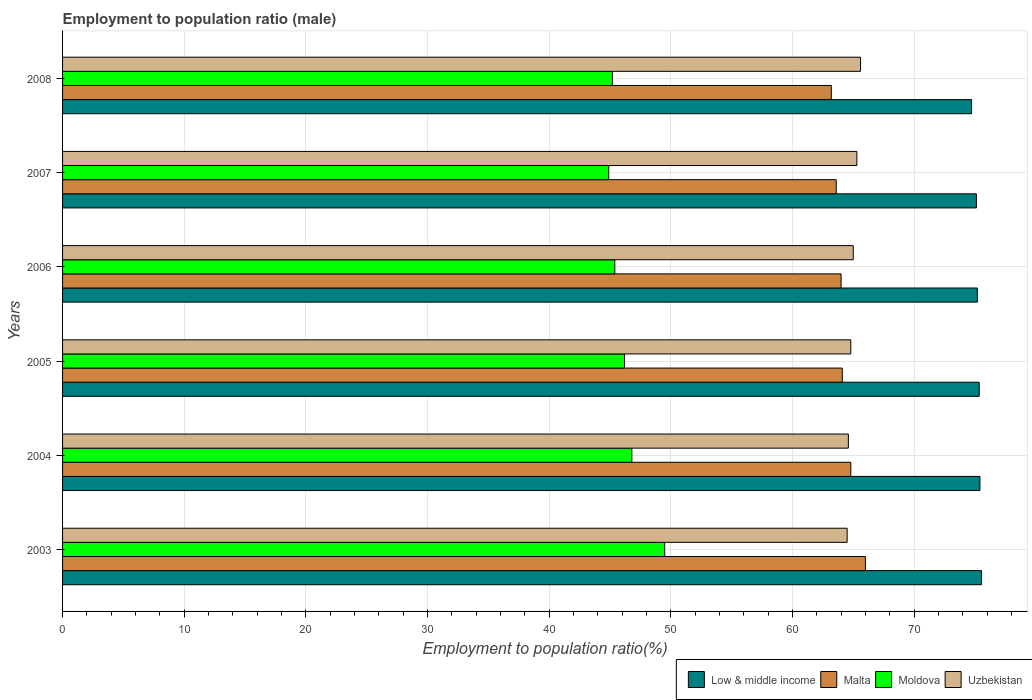Are the number of bars per tick equal to the number of legend labels?
Keep it short and to the point. Yes. Are the number of bars on each tick of the Y-axis equal?
Provide a succinct answer. Yes. How many bars are there on the 5th tick from the top?
Provide a succinct answer. 4. How many bars are there on the 5th tick from the bottom?
Keep it short and to the point. 4. In how many cases, is the number of bars for a given year not equal to the number of legend labels?
Offer a very short reply. 0. What is the employment to population ratio in Low & middle income in 2004?
Ensure brevity in your answer.  75.41. Across all years, what is the maximum employment to population ratio in Malta?
Make the answer very short. 66. Across all years, what is the minimum employment to population ratio in Moldova?
Your answer should be very brief. 44.9. In which year was the employment to population ratio in Low & middle income minimum?
Your answer should be very brief. 2008. What is the total employment to population ratio in Uzbekistan in the graph?
Offer a very short reply. 389.8. What is the difference between the employment to population ratio in Low & middle income in 2003 and that in 2007?
Your answer should be very brief. 0.42. What is the difference between the employment to population ratio in Low & middle income in 2008 and the employment to population ratio in Moldova in 2007?
Provide a short and direct response. 29.83. What is the average employment to population ratio in Moldova per year?
Make the answer very short. 46.33. In the year 2005, what is the difference between the employment to population ratio in Low & middle income and employment to population ratio in Malta?
Keep it short and to the point. 11.26. In how many years, is the employment to population ratio in Malta greater than 48 %?
Your response must be concise. 6. What is the ratio of the employment to population ratio in Low & middle income in 2003 to that in 2006?
Keep it short and to the point. 1. Is the employment to population ratio in Uzbekistan in 2003 less than that in 2004?
Offer a very short reply. Yes. What is the difference between the highest and the second highest employment to population ratio in Uzbekistan?
Give a very brief answer. 0.3. What is the difference between the highest and the lowest employment to population ratio in Malta?
Ensure brevity in your answer.  2.8. In how many years, is the employment to population ratio in Low & middle income greater than the average employment to population ratio in Low & middle income taken over all years?
Offer a very short reply. 3. Is the sum of the employment to population ratio in Low & middle income in 2004 and 2007 greater than the maximum employment to population ratio in Malta across all years?
Your response must be concise. Yes. What does the 3rd bar from the top in 2007 represents?
Your response must be concise. Malta. Is it the case that in every year, the sum of the employment to population ratio in Malta and employment to population ratio in Uzbekistan is greater than the employment to population ratio in Low & middle income?
Provide a succinct answer. Yes. How many bars are there?
Provide a succinct answer. 24. Are all the bars in the graph horizontal?
Provide a succinct answer. Yes. Are the values on the major ticks of X-axis written in scientific E-notation?
Keep it short and to the point. No. Does the graph contain any zero values?
Provide a short and direct response. No. Where does the legend appear in the graph?
Ensure brevity in your answer.  Bottom right. How many legend labels are there?
Provide a short and direct response. 4. What is the title of the graph?
Offer a very short reply. Employment to population ratio (male). What is the label or title of the X-axis?
Ensure brevity in your answer.  Employment to population ratio(%). What is the Employment to population ratio(%) of Low & middle income in 2003?
Make the answer very short. 75.55. What is the Employment to population ratio(%) in Malta in 2003?
Provide a succinct answer. 66. What is the Employment to population ratio(%) in Moldova in 2003?
Keep it short and to the point. 49.5. What is the Employment to population ratio(%) in Uzbekistan in 2003?
Make the answer very short. 64.5. What is the Employment to population ratio(%) of Low & middle income in 2004?
Your answer should be very brief. 75.41. What is the Employment to population ratio(%) in Malta in 2004?
Make the answer very short. 64.8. What is the Employment to population ratio(%) in Moldova in 2004?
Your response must be concise. 46.8. What is the Employment to population ratio(%) in Uzbekistan in 2004?
Offer a very short reply. 64.6. What is the Employment to population ratio(%) of Low & middle income in 2005?
Your response must be concise. 75.36. What is the Employment to population ratio(%) in Malta in 2005?
Make the answer very short. 64.1. What is the Employment to population ratio(%) of Moldova in 2005?
Your answer should be compact. 46.2. What is the Employment to population ratio(%) of Uzbekistan in 2005?
Your response must be concise. 64.8. What is the Employment to population ratio(%) of Low & middle income in 2006?
Offer a very short reply. 75.2. What is the Employment to population ratio(%) in Moldova in 2006?
Make the answer very short. 45.4. What is the Employment to population ratio(%) in Low & middle income in 2007?
Your response must be concise. 75.13. What is the Employment to population ratio(%) of Malta in 2007?
Give a very brief answer. 63.6. What is the Employment to population ratio(%) of Moldova in 2007?
Give a very brief answer. 44.9. What is the Employment to population ratio(%) of Uzbekistan in 2007?
Offer a very short reply. 65.3. What is the Employment to population ratio(%) of Low & middle income in 2008?
Ensure brevity in your answer.  74.73. What is the Employment to population ratio(%) of Malta in 2008?
Ensure brevity in your answer.  63.2. What is the Employment to population ratio(%) in Moldova in 2008?
Your answer should be very brief. 45.2. What is the Employment to population ratio(%) of Uzbekistan in 2008?
Provide a short and direct response. 65.6. Across all years, what is the maximum Employment to population ratio(%) of Low & middle income?
Provide a short and direct response. 75.55. Across all years, what is the maximum Employment to population ratio(%) in Moldova?
Make the answer very short. 49.5. Across all years, what is the maximum Employment to population ratio(%) in Uzbekistan?
Offer a terse response. 65.6. Across all years, what is the minimum Employment to population ratio(%) of Low & middle income?
Offer a terse response. 74.73. Across all years, what is the minimum Employment to population ratio(%) in Malta?
Your answer should be compact. 63.2. Across all years, what is the minimum Employment to population ratio(%) of Moldova?
Keep it short and to the point. 44.9. Across all years, what is the minimum Employment to population ratio(%) of Uzbekistan?
Ensure brevity in your answer.  64.5. What is the total Employment to population ratio(%) in Low & middle income in the graph?
Ensure brevity in your answer.  451.38. What is the total Employment to population ratio(%) of Malta in the graph?
Offer a very short reply. 385.7. What is the total Employment to population ratio(%) of Moldova in the graph?
Offer a terse response. 278. What is the total Employment to population ratio(%) in Uzbekistan in the graph?
Provide a short and direct response. 389.8. What is the difference between the Employment to population ratio(%) in Low & middle income in 2003 and that in 2004?
Offer a terse response. 0.13. What is the difference between the Employment to population ratio(%) of Uzbekistan in 2003 and that in 2004?
Make the answer very short. -0.1. What is the difference between the Employment to population ratio(%) of Low & middle income in 2003 and that in 2005?
Your answer should be very brief. 0.19. What is the difference between the Employment to population ratio(%) in Low & middle income in 2003 and that in 2006?
Your answer should be very brief. 0.35. What is the difference between the Employment to population ratio(%) in Malta in 2003 and that in 2006?
Keep it short and to the point. 2. What is the difference between the Employment to population ratio(%) of Moldova in 2003 and that in 2006?
Provide a succinct answer. 4.1. What is the difference between the Employment to population ratio(%) of Uzbekistan in 2003 and that in 2006?
Your answer should be very brief. -0.5. What is the difference between the Employment to population ratio(%) of Low & middle income in 2003 and that in 2007?
Offer a terse response. 0.42. What is the difference between the Employment to population ratio(%) in Malta in 2003 and that in 2007?
Provide a succinct answer. 2.4. What is the difference between the Employment to population ratio(%) in Low & middle income in 2003 and that in 2008?
Your response must be concise. 0.82. What is the difference between the Employment to population ratio(%) in Uzbekistan in 2003 and that in 2008?
Give a very brief answer. -1.1. What is the difference between the Employment to population ratio(%) in Low & middle income in 2004 and that in 2005?
Your answer should be compact. 0.06. What is the difference between the Employment to population ratio(%) of Malta in 2004 and that in 2005?
Your response must be concise. 0.7. What is the difference between the Employment to population ratio(%) of Moldova in 2004 and that in 2005?
Your answer should be very brief. 0.6. What is the difference between the Employment to population ratio(%) of Uzbekistan in 2004 and that in 2005?
Keep it short and to the point. -0.2. What is the difference between the Employment to population ratio(%) of Low & middle income in 2004 and that in 2006?
Give a very brief answer. 0.21. What is the difference between the Employment to population ratio(%) in Moldova in 2004 and that in 2006?
Provide a succinct answer. 1.4. What is the difference between the Employment to population ratio(%) in Uzbekistan in 2004 and that in 2006?
Your answer should be compact. -0.4. What is the difference between the Employment to population ratio(%) of Low & middle income in 2004 and that in 2007?
Provide a succinct answer. 0.29. What is the difference between the Employment to population ratio(%) in Moldova in 2004 and that in 2007?
Offer a very short reply. 1.9. What is the difference between the Employment to population ratio(%) in Uzbekistan in 2004 and that in 2007?
Provide a short and direct response. -0.7. What is the difference between the Employment to population ratio(%) of Low & middle income in 2004 and that in 2008?
Your response must be concise. 0.69. What is the difference between the Employment to population ratio(%) in Malta in 2004 and that in 2008?
Ensure brevity in your answer.  1.6. What is the difference between the Employment to population ratio(%) of Uzbekistan in 2004 and that in 2008?
Your answer should be very brief. -1. What is the difference between the Employment to population ratio(%) in Low & middle income in 2005 and that in 2006?
Your response must be concise. 0.15. What is the difference between the Employment to population ratio(%) of Low & middle income in 2005 and that in 2007?
Your response must be concise. 0.23. What is the difference between the Employment to population ratio(%) of Malta in 2005 and that in 2007?
Your response must be concise. 0.5. What is the difference between the Employment to population ratio(%) in Uzbekistan in 2005 and that in 2007?
Your answer should be very brief. -0.5. What is the difference between the Employment to population ratio(%) in Low & middle income in 2005 and that in 2008?
Make the answer very short. 0.63. What is the difference between the Employment to population ratio(%) in Moldova in 2005 and that in 2008?
Your answer should be very brief. 1. What is the difference between the Employment to population ratio(%) in Low & middle income in 2006 and that in 2007?
Your answer should be very brief. 0.08. What is the difference between the Employment to population ratio(%) in Low & middle income in 2006 and that in 2008?
Provide a short and direct response. 0.47. What is the difference between the Employment to population ratio(%) of Uzbekistan in 2006 and that in 2008?
Make the answer very short. -0.6. What is the difference between the Employment to population ratio(%) in Low & middle income in 2007 and that in 2008?
Ensure brevity in your answer.  0.4. What is the difference between the Employment to population ratio(%) in Low & middle income in 2003 and the Employment to population ratio(%) in Malta in 2004?
Provide a short and direct response. 10.75. What is the difference between the Employment to population ratio(%) in Low & middle income in 2003 and the Employment to population ratio(%) in Moldova in 2004?
Your answer should be compact. 28.75. What is the difference between the Employment to population ratio(%) of Low & middle income in 2003 and the Employment to population ratio(%) of Uzbekistan in 2004?
Your answer should be compact. 10.95. What is the difference between the Employment to population ratio(%) in Malta in 2003 and the Employment to population ratio(%) in Moldova in 2004?
Make the answer very short. 19.2. What is the difference between the Employment to population ratio(%) in Moldova in 2003 and the Employment to population ratio(%) in Uzbekistan in 2004?
Your answer should be very brief. -15.1. What is the difference between the Employment to population ratio(%) in Low & middle income in 2003 and the Employment to population ratio(%) in Malta in 2005?
Provide a short and direct response. 11.45. What is the difference between the Employment to population ratio(%) in Low & middle income in 2003 and the Employment to population ratio(%) in Moldova in 2005?
Your response must be concise. 29.35. What is the difference between the Employment to population ratio(%) in Low & middle income in 2003 and the Employment to population ratio(%) in Uzbekistan in 2005?
Ensure brevity in your answer.  10.75. What is the difference between the Employment to population ratio(%) in Malta in 2003 and the Employment to population ratio(%) in Moldova in 2005?
Give a very brief answer. 19.8. What is the difference between the Employment to population ratio(%) of Moldova in 2003 and the Employment to population ratio(%) of Uzbekistan in 2005?
Offer a very short reply. -15.3. What is the difference between the Employment to population ratio(%) in Low & middle income in 2003 and the Employment to population ratio(%) in Malta in 2006?
Your answer should be compact. 11.55. What is the difference between the Employment to population ratio(%) of Low & middle income in 2003 and the Employment to population ratio(%) of Moldova in 2006?
Your answer should be compact. 30.15. What is the difference between the Employment to population ratio(%) of Low & middle income in 2003 and the Employment to population ratio(%) of Uzbekistan in 2006?
Your answer should be compact. 10.55. What is the difference between the Employment to population ratio(%) in Malta in 2003 and the Employment to population ratio(%) in Moldova in 2006?
Make the answer very short. 20.6. What is the difference between the Employment to population ratio(%) of Malta in 2003 and the Employment to population ratio(%) of Uzbekistan in 2006?
Make the answer very short. 1. What is the difference between the Employment to population ratio(%) of Moldova in 2003 and the Employment to population ratio(%) of Uzbekistan in 2006?
Offer a terse response. -15.5. What is the difference between the Employment to population ratio(%) of Low & middle income in 2003 and the Employment to population ratio(%) of Malta in 2007?
Offer a very short reply. 11.95. What is the difference between the Employment to population ratio(%) in Low & middle income in 2003 and the Employment to population ratio(%) in Moldova in 2007?
Provide a succinct answer. 30.65. What is the difference between the Employment to population ratio(%) in Low & middle income in 2003 and the Employment to population ratio(%) in Uzbekistan in 2007?
Provide a short and direct response. 10.25. What is the difference between the Employment to population ratio(%) in Malta in 2003 and the Employment to population ratio(%) in Moldova in 2007?
Make the answer very short. 21.1. What is the difference between the Employment to population ratio(%) in Moldova in 2003 and the Employment to population ratio(%) in Uzbekistan in 2007?
Provide a short and direct response. -15.8. What is the difference between the Employment to population ratio(%) in Low & middle income in 2003 and the Employment to population ratio(%) in Malta in 2008?
Provide a short and direct response. 12.35. What is the difference between the Employment to population ratio(%) of Low & middle income in 2003 and the Employment to population ratio(%) of Moldova in 2008?
Your answer should be compact. 30.35. What is the difference between the Employment to population ratio(%) of Low & middle income in 2003 and the Employment to population ratio(%) of Uzbekistan in 2008?
Your answer should be compact. 9.95. What is the difference between the Employment to population ratio(%) in Malta in 2003 and the Employment to population ratio(%) in Moldova in 2008?
Your answer should be compact. 20.8. What is the difference between the Employment to population ratio(%) in Moldova in 2003 and the Employment to population ratio(%) in Uzbekistan in 2008?
Keep it short and to the point. -16.1. What is the difference between the Employment to population ratio(%) of Low & middle income in 2004 and the Employment to population ratio(%) of Malta in 2005?
Your answer should be compact. 11.31. What is the difference between the Employment to population ratio(%) in Low & middle income in 2004 and the Employment to population ratio(%) in Moldova in 2005?
Give a very brief answer. 29.21. What is the difference between the Employment to population ratio(%) of Low & middle income in 2004 and the Employment to population ratio(%) of Uzbekistan in 2005?
Your answer should be very brief. 10.62. What is the difference between the Employment to population ratio(%) in Malta in 2004 and the Employment to population ratio(%) in Moldova in 2005?
Provide a succinct answer. 18.6. What is the difference between the Employment to population ratio(%) of Moldova in 2004 and the Employment to population ratio(%) of Uzbekistan in 2005?
Your response must be concise. -18. What is the difference between the Employment to population ratio(%) of Low & middle income in 2004 and the Employment to population ratio(%) of Malta in 2006?
Make the answer very short. 11.41. What is the difference between the Employment to population ratio(%) in Low & middle income in 2004 and the Employment to population ratio(%) in Moldova in 2006?
Provide a short and direct response. 30.02. What is the difference between the Employment to population ratio(%) of Low & middle income in 2004 and the Employment to population ratio(%) of Uzbekistan in 2006?
Make the answer very short. 10.41. What is the difference between the Employment to population ratio(%) of Malta in 2004 and the Employment to population ratio(%) of Uzbekistan in 2006?
Provide a succinct answer. -0.2. What is the difference between the Employment to population ratio(%) of Moldova in 2004 and the Employment to population ratio(%) of Uzbekistan in 2006?
Make the answer very short. -18.2. What is the difference between the Employment to population ratio(%) of Low & middle income in 2004 and the Employment to population ratio(%) of Malta in 2007?
Offer a terse response. 11.81. What is the difference between the Employment to population ratio(%) in Low & middle income in 2004 and the Employment to population ratio(%) in Moldova in 2007?
Keep it short and to the point. 30.52. What is the difference between the Employment to population ratio(%) in Low & middle income in 2004 and the Employment to population ratio(%) in Uzbekistan in 2007?
Your response must be concise. 10.12. What is the difference between the Employment to population ratio(%) of Moldova in 2004 and the Employment to population ratio(%) of Uzbekistan in 2007?
Your answer should be very brief. -18.5. What is the difference between the Employment to population ratio(%) of Low & middle income in 2004 and the Employment to population ratio(%) of Malta in 2008?
Your answer should be compact. 12.21. What is the difference between the Employment to population ratio(%) in Low & middle income in 2004 and the Employment to population ratio(%) in Moldova in 2008?
Provide a short and direct response. 30.21. What is the difference between the Employment to population ratio(%) of Low & middle income in 2004 and the Employment to population ratio(%) of Uzbekistan in 2008?
Make the answer very short. 9.81. What is the difference between the Employment to population ratio(%) in Malta in 2004 and the Employment to population ratio(%) in Moldova in 2008?
Your answer should be very brief. 19.6. What is the difference between the Employment to population ratio(%) of Moldova in 2004 and the Employment to population ratio(%) of Uzbekistan in 2008?
Your answer should be compact. -18.8. What is the difference between the Employment to population ratio(%) of Low & middle income in 2005 and the Employment to population ratio(%) of Malta in 2006?
Provide a succinct answer. 11.36. What is the difference between the Employment to population ratio(%) in Low & middle income in 2005 and the Employment to population ratio(%) in Moldova in 2006?
Your answer should be very brief. 29.96. What is the difference between the Employment to population ratio(%) of Low & middle income in 2005 and the Employment to population ratio(%) of Uzbekistan in 2006?
Give a very brief answer. 10.36. What is the difference between the Employment to population ratio(%) of Malta in 2005 and the Employment to population ratio(%) of Moldova in 2006?
Offer a terse response. 18.7. What is the difference between the Employment to population ratio(%) of Moldova in 2005 and the Employment to population ratio(%) of Uzbekistan in 2006?
Your answer should be compact. -18.8. What is the difference between the Employment to population ratio(%) in Low & middle income in 2005 and the Employment to population ratio(%) in Malta in 2007?
Offer a terse response. 11.76. What is the difference between the Employment to population ratio(%) of Low & middle income in 2005 and the Employment to population ratio(%) of Moldova in 2007?
Your response must be concise. 30.46. What is the difference between the Employment to population ratio(%) of Low & middle income in 2005 and the Employment to population ratio(%) of Uzbekistan in 2007?
Offer a very short reply. 10.06. What is the difference between the Employment to population ratio(%) in Moldova in 2005 and the Employment to population ratio(%) in Uzbekistan in 2007?
Make the answer very short. -19.1. What is the difference between the Employment to population ratio(%) of Low & middle income in 2005 and the Employment to population ratio(%) of Malta in 2008?
Make the answer very short. 12.16. What is the difference between the Employment to population ratio(%) in Low & middle income in 2005 and the Employment to population ratio(%) in Moldova in 2008?
Keep it short and to the point. 30.16. What is the difference between the Employment to population ratio(%) of Low & middle income in 2005 and the Employment to population ratio(%) of Uzbekistan in 2008?
Your answer should be compact. 9.76. What is the difference between the Employment to population ratio(%) in Malta in 2005 and the Employment to population ratio(%) in Uzbekistan in 2008?
Provide a succinct answer. -1.5. What is the difference between the Employment to population ratio(%) of Moldova in 2005 and the Employment to population ratio(%) of Uzbekistan in 2008?
Keep it short and to the point. -19.4. What is the difference between the Employment to population ratio(%) in Low & middle income in 2006 and the Employment to population ratio(%) in Malta in 2007?
Offer a terse response. 11.6. What is the difference between the Employment to population ratio(%) of Low & middle income in 2006 and the Employment to population ratio(%) of Moldova in 2007?
Provide a short and direct response. 30.3. What is the difference between the Employment to population ratio(%) of Low & middle income in 2006 and the Employment to population ratio(%) of Uzbekistan in 2007?
Offer a terse response. 9.9. What is the difference between the Employment to population ratio(%) in Malta in 2006 and the Employment to population ratio(%) in Moldova in 2007?
Provide a succinct answer. 19.1. What is the difference between the Employment to population ratio(%) of Malta in 2006 and the Employment to population ratio(%) of Uzbekistan in 2007?
Your answer should be compact. -1.3. What is the difference between the Employment to population ratio(%) of Moldova in 2006 and the Employment to population ratio(%) of Uzbekistan in 2007?
Provide a succinct answer. -19.9. What is the difference between the Employment to population ratio(%) of Low & middle income in 2006 and the Employment to population ratio(%) of Malta in 2008?
Provide a succinct answer. 12. What is the difference between the Employment to population ratio(%) of Low & middle income in 2006 and the Employment to population ratio(%) of Moldova in 2008?
Your response must be concise. 30. What is the difference between the Employment to population ratio(%) in Low & middle income in 2006 and the Employment to population ratio(%) in Uzbekistan in 2008?
Your response must be concise. 9.6. What is the difference between the Employment to population ratio(%) of Malta in 2006 and the Employment to population ratio(%) of Moldova in 2008?
Give a very brief answer. 18.8. What is the difference between the Employment to population ratio(%) of Moldova in 2006 and the Employment to population ratio(%) of Uzbekistan in 2008?
Give a very brief answer. -20.2. What is the difference between the Employment to population ratio(%) of Low & middle income in 2007 and the Employment to population ratio(%) of Malta in 2008?
Provide a succinct answer. 11.93. What is the difference between the Employment to population ratio(%) of Low & middle income in 2007 and the Employment to population ratio(%) of Moldova in 2008?
Offer a terse response. 29.93. What is the difference between the Employment to population ratio(%) of Low & middle income in 2007 and the Employment to population ratio(%) of Uzbekistan in 2008?
Provide a short and direct response. 9.53. What is the difference between the Employment to population ratio(%) in Malta in 2007 and the Employment to population ratio(%) in Moldova in 2008?
Give a very brief answer. 18.4. What is the difference between the Employment to population ratio(%) of Malta in 2007 and the Employment to population ratio(%) of Uzbekistan in 2008?
Make the answer very short. -2. What is the difference between the Employment to population ratio(%) of Moldova in 2007 and the Employment to population ratio(%) of Uzbekistan in 2008?
Ensure brevity in your answer.  -20.7. What is the average Employment to population ratio(%) of Low & middle income per year?
Give a very brief answer. 75.23. What is the average Employment to population ratio(%) of Malta per year?
Offer a very short reply. 64.28. What is the average Employment to population ratio(%) of Moldova per year?
Make the answer very short. 46.33. What is the average Employment to population ratio(%) of Uzbekistan per year?
Give a very brief answer. 64.97. In the year 2003, what is the difference between the Employment to population ratio(%) of Low & middle income and Employment to population ratio(%) of Malta?
Make the answer very short. 9.55. In the year 2003, what is the difference between the Employment to population ratio(%) of Low & middle income and Employment to population ratio(%) of Moldova?
Give a very brief answer. 26.05. In the year 2003, what is the difference between the Employment to population ratio(%) of Low & middle income and Employment to population ratio(%) of Uzbekistan?
Your answer should be very brief. 11.05. In the year 2003, what is the difference between the Employment to population ratio(%) in Malta and Employment to population ratio(%) in Uzbekistan?
Offer a terse response. 1.5. In the year 2004, what is the difference between the Employment to population ratio(%) in Low & middle income and Employment to population ratio(%) in Malta?
Make the answer very short. 10.62. In the year 2004, what is the difference between the Employment to population ratio(%) in Low & middle income and Employment to population ratio(%) in Moldova?
Keep it short and to the point. 28.61. In the year 2004, what is the difference between the Employment to population ratio(%) of Low & middle income and Employment to population ratio(%) of Uzbekistan?
Make the answer very short. 10.81. In the year 2004, what is the difference between the Employment to population ratio(%) of Moldova and Employment to population ratio(%) of Uzbekistan?
Your response must be concise. -17.8. In the year 2005, what is the difference between the Employment to population ratio(%) in Low & middle income and Employment to population ratio(%) in Malta?
Make the answer very short. 11.26. In the year 2005, what is the difference between the Employment to population ratio(%) of Low & middle income and Employment to population ratio(%) of Moldova?
Your answer should be compact. 29.16. In the year 2005, what is the difference between the Employment to population ratio(%) of Low & middle income and Employment to population ratio(%) of Uzbekistan?
Keep it short and to the point. 10.56. In the year 2005, what is the difference between the Employment to population ratio(%) of Moldova and Employment to population ratio(%) of Uzbekistan?
Offer a terse response. -18.6. In the year 2006, what is the difference between the Employment to population ratio(%) in Low & middle income and Employment to population ratio(%) in Malta?
Make the answer very short. 11.2. In the year 2006, what is the difference between the Employment to population ratio(%) of Low & middle income and Employment to population ratio(%) of Moldova?
Give a very brief answer. 29.8. In the year 2006, what is the difference between the Employment to population ratio(%) in Low & middle income and Employment to population ratio(%) in Uzbekistan?
Your answer should be very brief. 10.2. In the year 2006, what is the difference between the Employment to population ratio(%) in Malta and Employment to population ratio(%) in Moldova?
Your response must be concise. 18.6. In the year 2006, what is the difference between the Employment to population ratio(%) of Moldova and Employment to population ratio(%) of Uzbekistan?
Ensure brevity in your answer.  -19.6. In the year 2007, what is the difference between the Employment to population ratio(%) in Low & middle income and Employment to population ratio(%) in Malta?
Offer a terse response. 11.53. In the year 2007, what is the difference between the Employment to population ratio(%) of Low & middle income and Employment to population ratio(%) of Moldova?
Provide a short and direct response. 30.23. In the year 2007, what is the difference between the Employment to population ratio(%) in Low & middle income and Employment to population ratio(%) in Uzbekistan?
Your answer should be very brief. 9.83. In the year 2007, what is the difference between the Employment to population ratio(%) in Malta and Employment to population ratio(%) in Uzbekistan?
Your response must be concise. -1.7. In the year 2007, what is the difference between the Employment to population ratio(%) in Moldova and Employment to population ratio(%) in Uzbekistan?
Your response must be concise. -20.4. In the year 2008, what is the difference between the Employment to population ratio(%) in Low & middle income and Employment to population ratio(%) in Malta?
Offer a terse response. 11.53. In the year 2008, what is the difference between the Employment to population ratio(%) in Low & middle income and Employment to population ratio(%) in Moldova?
Offer a very short reply. 29.53. In the year 2008, what is the difference between the Employment to population ratio(%) in Low & middle income and Employment to population ratio(%) in Uzbekistan?
Make the answer very short. 9.13. In the year 2008, what is the difference between the Employment to population ratio(%) in Malta and Employment to population ratio(%) in Uzbekistan?
Offer a terse response. -2.4. In the year 2008, what is the difference between the Employment to population ratio(%) of Moldova and Employment to population ratio(%) of Uzbekistan?
Your answer should be compact. -20.4. What is the ratio of the Employment to population ratio(%) in Malta in 2003 to that in 2004?
Your answer should be compact. 1.02. What is the ratio of the Employment to population ratio(%) in Moldova in 2003 to that in 2004?
Offer a terse response. 1.06. What is the ratio of the Employment to population ratio(%) of Uzbekistan in 2003 to that in 2004?
Offer a very short reply. 1. What is the ratio of the Employment to population ratio(%) of Malta in 2003 to that in 2005?
Offer a very short reply. 1.03. What is the ratio of the Employment to population ratio(%) in Moldova in 2003 to that in 2005?
Keep it short and to the point. 1.07. What is the ratio of the Employment to population ratio(%) of Malta in 2003 to that in 2006?
Keep it short and to the point. 1.03. What is the ratio of the Employment to population ratio(%) of Moldova in 2003 to that in 2006?
Your answer should be very brief. 1.09. What is the ratio of the Employment to population ratio(%) of Uzbekistan in 2003 to that in 2006?
Your response must be concise. 0.99. What is the ratio of the Employment to population ratio(%) in Low & middle income in 2003 to that in 2007?
Give a very brief answer. 1.01. What is the ratio of the Employment to population ratio(%) of Malta in 2003 to that in 2007?
Provide a short and direct response. 1.04. What is the ratio of the Employment to population ratio(%) in Moldova in 2003 to that in 2007?
Offer a terse response. 1.1. What is the ratio of the Employment to population ratio(%) of Uzbekistan in 2003 to that in 2007?
Provide a succinct answer. 0.99. What is the ratio of the Employment to population ratio(%) of Low & middle income in 2003 to that in 2008?
Offer a very short reply. 1.01. What is the ratio of the Employment to population ratio(%) of Malta in 2003 to that in 2008?
Give a very brief answer. 1.04. What is the ratio of the Employment to population ratio(%) in Moldova in 2003 to that in 2008?
Your answer should be compact. 1.1. What is the ratio of the Employment to population ratio(%) in Uzbekistan in 2003 to that in 2008?
Give a very brief answer. 0.98. What is the ratio of the Employment to population ratio(%) of Malta in 2004 to that in 2005?
Keep it short and to the point. 1.01. What is the ratio of the Employment to population ratio(%) of Moldova in 2004 to that in 2005?
Offer a very short reply. 1.01. What is the ratio of the Employment to population ratio(%) of Low & middle income in 2004 to that in 2006?
Make the answer very short. 1. What is the ratio of the Employment to population ratio(%) in Malta in 2004 to that in 2006?
Give a very brief answer. 1.01. What is the ratio of the Employment to population ratio(%) of Moldova in 2004 to that in 2006?
Offer a terse response. 1.03. What is the ratio of the Employment to population ratio(%) of Uzbekistan in 2004 to that in 2006?
Give a very brief answer. 0.99. What is the ratio of the Employment to population ratio(%) in Low & middle income in 2004 to that in 2007?
Offer a terse response. 1. What is the ratio of the Employment to population ratio(%) in Malta in 2004 to that in 2007?
Give a very brief answer. 1.02. What is the ratio of the Employment to population ratio(%) in Moldova in 2004 to that in 2007?
Your response must be concise. 1.04. What is the ratio of the Employment to population ratio(%) in Uzbekistan in 2004 to that in 2007?
Provide a succinct answer. 0.99. What is the ratio of the Employment to population ratio(%) in Low & middle income in 2004 to that in 2008?
Provide a short and direct response. 1.01. What is the ratio of the Employment to population ratio(%) in Malta in 2004 to that in 2008?
Ensure brevity in your answer.  1.03. What is the ratio of the Employment to population ratio(%) in Moldova in 2004 to that in 2008?
Your answer should be very brief. 1.04. What is the ratio of the Employment to population ratio(%) of Uzbekistan in 2004 to that in 2008?
Provide a short and direct response. 0.98. What is the ratio of the Employment to population ratio(%) of Malta in 2005 to that in 2006?
Your answer should be compact. 1. What is the ratio of the Employment to population ratio(%) of Moldova in 2005 to that in 2006?
Your response must be concise. 1.02. What is the ratio of the Employment to population ratio(%) in Malta in 2005 to that in 2007?
Offer a very short reply. 1.01. What is the ratio of the Employment to population ratio(%) in Moldova in 2005 to that in 2007?
Your response must be concise. 1.03. What is the ratio of the Employment to population ratio(%) of Low & middle income in 2005 to that in 2008?
Provide a succinct answer. 1.01. What is the ratio of the Employment to population ratio(%) of Malta in 2005 to that in 2008?
Ensure brevity in your answer.  1.01. What is the ratio of the Employment to population ratio(%) of Moldova in 2005 to that in 2008?
Your response must be concise. 1.02. What is the ratio of the Employment to population ratio(%) of Uzbekistan in 2005 to that in 2008?
Your answer should be compact. 0.99. What is the ratio of the Employment to population ratio(%) of Moldova in 2006 to that in 2007?
Your answer should be compact. 1.01. What is the ratio of the Employment to population ratio(%) of Uzbekistan in 2006 to that in 2007?
Give a very brief answer. 1. What is the ratio of the Employment to population ratio(%) in Low & middle income in 2006 to that in 2008?
Your response must be concise. 1.01. What is the ratio of the Employment to population ratio(%) of Malta in 2006 to that in 2008?
Give a very brief answer. 1.01. What is the ratio of the Employment to population ratio(%) of Moldova in 2006 to that in 2008?
Provide a short and direct response. 1. What is the ratio of the Employment to population ratio(%) of Uzbekistan in 2006 to that in 2008?
Provide a short and direct response. 0.99. What is the ratio of the Employment to population ratio(%) of Low & middle income in 2007 to that in 2008?
Make the answer very short. 1.01. What is the difference between the highest and the second highest Employment to population ratio(%) of Low & middle income?
Provide a short and direct response. 0.13. What is the difference between the highest and the second highest Employment to population ratio(%) of Uzbekistan?
Your answer should be compact. 0.3. What is the difference between the highest and the lowest Employment to population ratio(%) in Low & middle income?
Keep it short and to the point. 0.82. What is the difference between the highest and the lowest Employment to population ratio(%) in Malta?
Your response must be concise. 2.8. What is the difference between the highest and the lowest Employment to population ratio(%) of Moldova?
Make the answer very short. 4.6. What is the difference between the highest and the lowest Employment to population ratio(%) in Uzbekistan?
Provide a short and direct response. 1.1. 